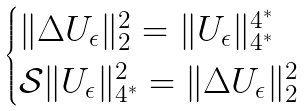Convert formula to latex. <formula><loc_0><loc_0><loc_500><loc_500>\begin{cases} \| \Delta U _ { \epsilon } \| _ { 2 } ^ { 2 } = \| U _ { \epsilon } \| _ { 4 ^ { * } } ^ { 4 ^ { * } } \\ \mathcal { S } \| U _ { \epsilon } \| _ { 4 ^ { * } } ^ { 2 } = \| \Delta U _ { \epsilon } \| _ { 2 } ^ { 2 } \\ \end{cases}</formula> 